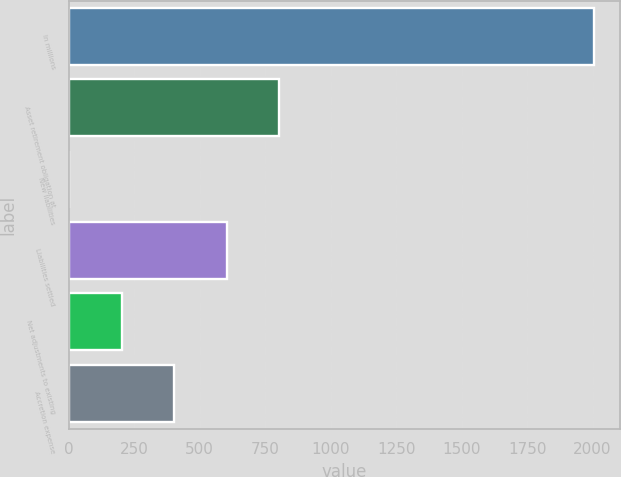Convert chart to OTSL. <chart><loc_0><loc_0><loc_500><loc_500><bar_chart><fcel>In millions<fcel>Asset retirement obligation at<fcel>New liabilities<fcel>Liabilities settled<fcel>Net adjustments to existing<fcel>Accretion expense<nl><fcel>2006<fcel>803<fcel>1<fcel>602.5<fcel>201.5<fcel>402<nl></chart> 